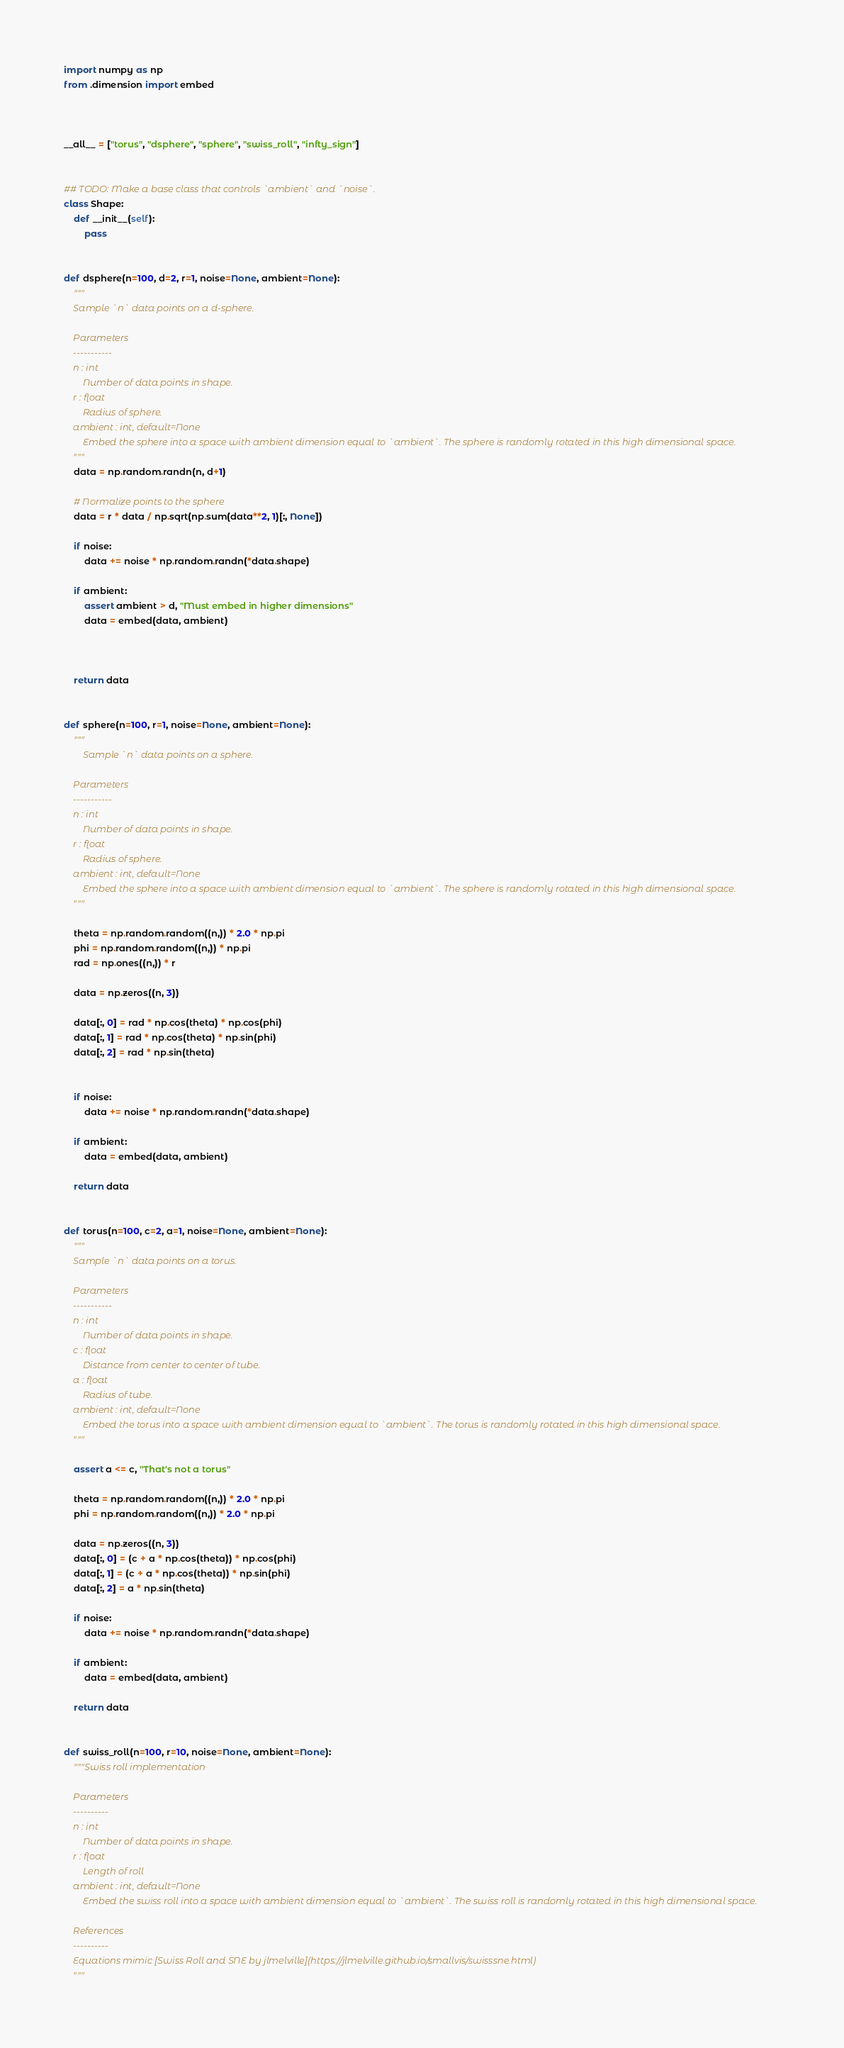<code> <loc_0><loc_0><loc_500><loc_500><_Python_>import numpy as np
from .dimension import embed



__all__ = ["torus", "dsphere", "sphere", "swiss_roll", "infty_sign"]


## TODO: Make a base class that controls `ambient` and `noise`.
class Shape:
    def __init__(self):
        pass


def dsphere(n=100, d=2, r=1, noise=None, ambient=None):
    """
    Sample `n` data points on a d-sphere.

    Parameters
    -----------
    n : int
        Number of data points in shape.
    r : float
        Radius of sphere.
    ambient : int, default=None
        Embed the sphere into a space with ambient dimension equal to `ambient`. The sphere is randomly rotated in this high dimensional space.
    """
    data = np.random.randn(n, d+1)

    # Normalize points to the sphere
    data = r * data / np.sqrt(np.sum(data**2, 1)[:, None]) 

    if noise: 
        data += noise * np.random.randn(*data.shape)

    if ambient:
        assert ambient > d, "Must embed in higher dimensions"
        data = embed(data, ambient)



    return data


def sphere(n=100, r=1, noise=None, ambient=None):
    """
        Sample `n` data points on a sphere.

    Parameters
    -----------
    n : int
        Number of data points in shape.
    r : float
        Radius of sphere.
    ambient : int, default=None
        Embed the sphere into a space with ambient dimension equal to `ambient`. The sphere is randomly rotated in this high dimensional space.
    """

    theta = np.random.random((n,)) * 2.0 * np.pi
    phi = np.random.random((n,)) * np.pi
    rad = np.ones((n,)) * r

    data = np.zeros((n, 3))

    data[:, 0] = rad * np.cos(theta) * np.cos(phi)
    data[:, 1] = rad * np.cos(theta) * np.sin(phi)
    data[:, 2] = rad * np.sin(theta)


    if noise: 
        data += noise * np.random.randn(*data.shape)

    if ambient:
        data = embed(data, ambient)

    return data


def torus(n=100, c=2, a=1, noise=None, ambient=None):
    """
    Sample `n` data points on a torus.

    Parameters
    -----------
    n : int
        Number of data points in shape.
    c : float
        Distance from center to center of tube.
    a : float
        Radius of tube.
    ambient : int, default=None
        Embed the torus into a space with ambient dimension equal to `ambient`. The torus is randomly rotated in this high dimensional space.
    """

    assert a <= c, "That's not a torus"

    theta = np.random.random((n,)) * 2.0 * np.pi
    phi = np.random.random((n,)) * 2.0 * np.pi

    data = np.zeros((n, 3))
    data[:, 0] = (c + a * np.cos(theta)) * np.cos(phi)
    data[:, 1] = (c + a * np.cos(theta)) * np.sin(phi)
    data[:, 2] = a * np.sin(theta)

    if noise: 
        data += noise * np.random.randn(*data.shape)

    if ambient:
        data = embed(data, ambient)

    return data


def swiss_roll(n=100, r=10, noise=None, ambient=None):
    """Swiss roll implementation

    Parameters
    ----------
    n : int 
        Number of data points in shape.
    r : float
        Length of roll
    ambient : int, default=None
        Embed the swiss roll into a space with ambient dimension equal to `ambient`. The swiss roll is randomly rotated in this high dimensional space.

    References
    ----------
    Equations mimic [Swiss Roll and SNE by jlmelville](https://jlmelville.github.io/smallvis/swisssne.html)
    """
</code> 